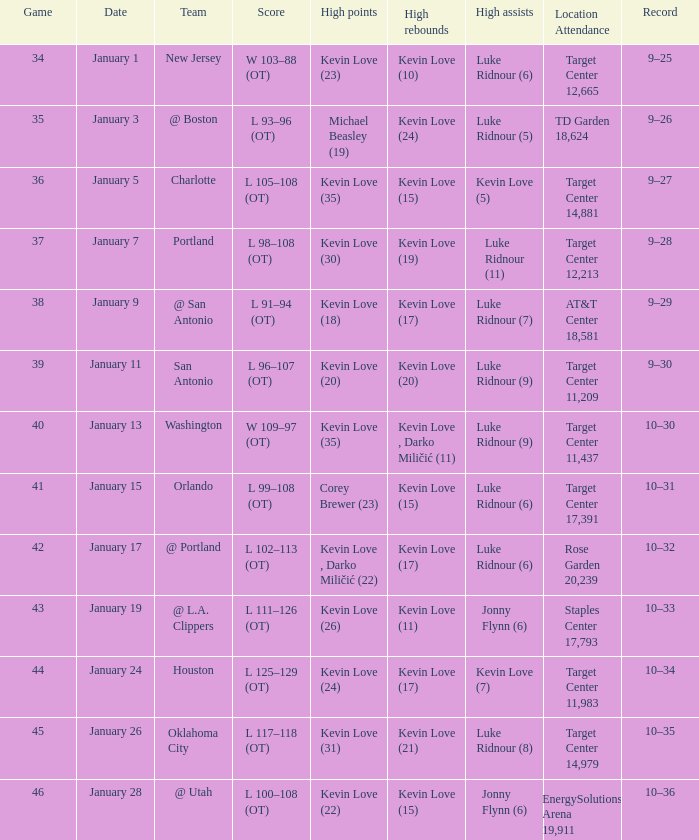What is the highest game with team @ l.a. clippers? 43.0. 